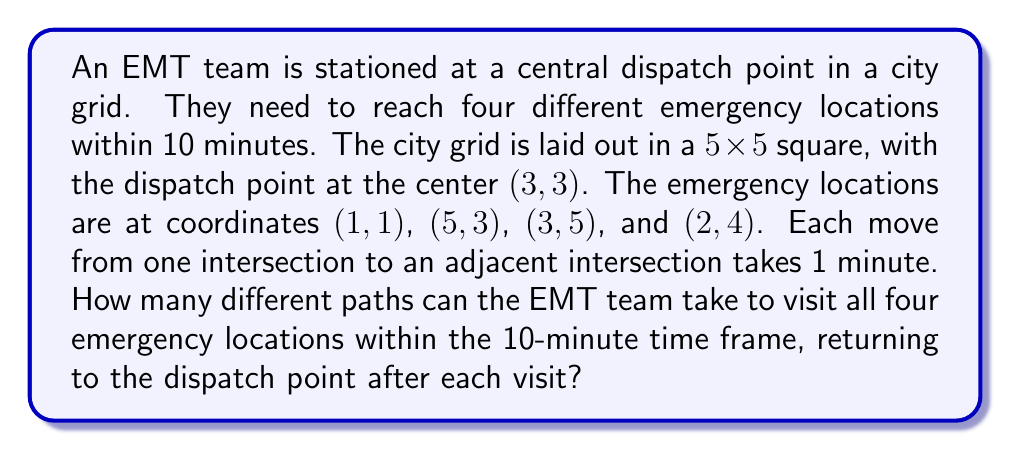Solve this math problem. Let's approach this step-by-step:

1) First, we need to calculate the distance (in minutes) from the dispatch point (3,3) to each emergency location:
   - To (1,1): $|3-1| + |3-1| = 4$ minutes
   - To (5,3): $|5-3| + |3-3| = 2$ minutes
   - To (3,5): $|3-3| + |5-3| = 2$ minutes
   - To (2,4): $|2-3| + |4-3| = 2$ minutes

2) The total time for visiting all locations and returning to dispatch each time is:
   $$(4 + 4) + (2 + 2) + (2 + 2) + (2 + 2) = 20$$ minutes

3) This exceeds the 10-minute time frame, so the EMT team can only visit two locations within the given time.

4) To calculate the number of paths, we need to:
   a) Choose 2 locations out of 4
   b) Determine the number of paths to each chosen location

5) Number of ways to choose 2 locations out of 4:
   $$\binom{4}{2} = \frac{4!}{2!(4-2)!} = 6$$

6) For each pair of locations, we need to calculate:
   (paths to first location) × (paths to second location)

7) Number of paths to each location:
   - To (1,1): $\binom{4+4}{4} = 70$ paths
   - To (5,3): $\binom{2+0}{2} = 1$ path
   - To (3,5): $\binom{0+2}{2} = 1$ path
   - To (2,4): $\binom{1+1}{1} = 2$ paths

8) Total number of paths for all possible pairs:
   $$(70 × 1) + (70 × 1) + (70 × 2) + (1 × 1) + (1 × 2) + (1 × 2) = 214$$

Therefore, there are 214 different paths the EMT team can take to visit two out of the four emergency locations within the 10-minute time frame.
Answer: 214 paths 